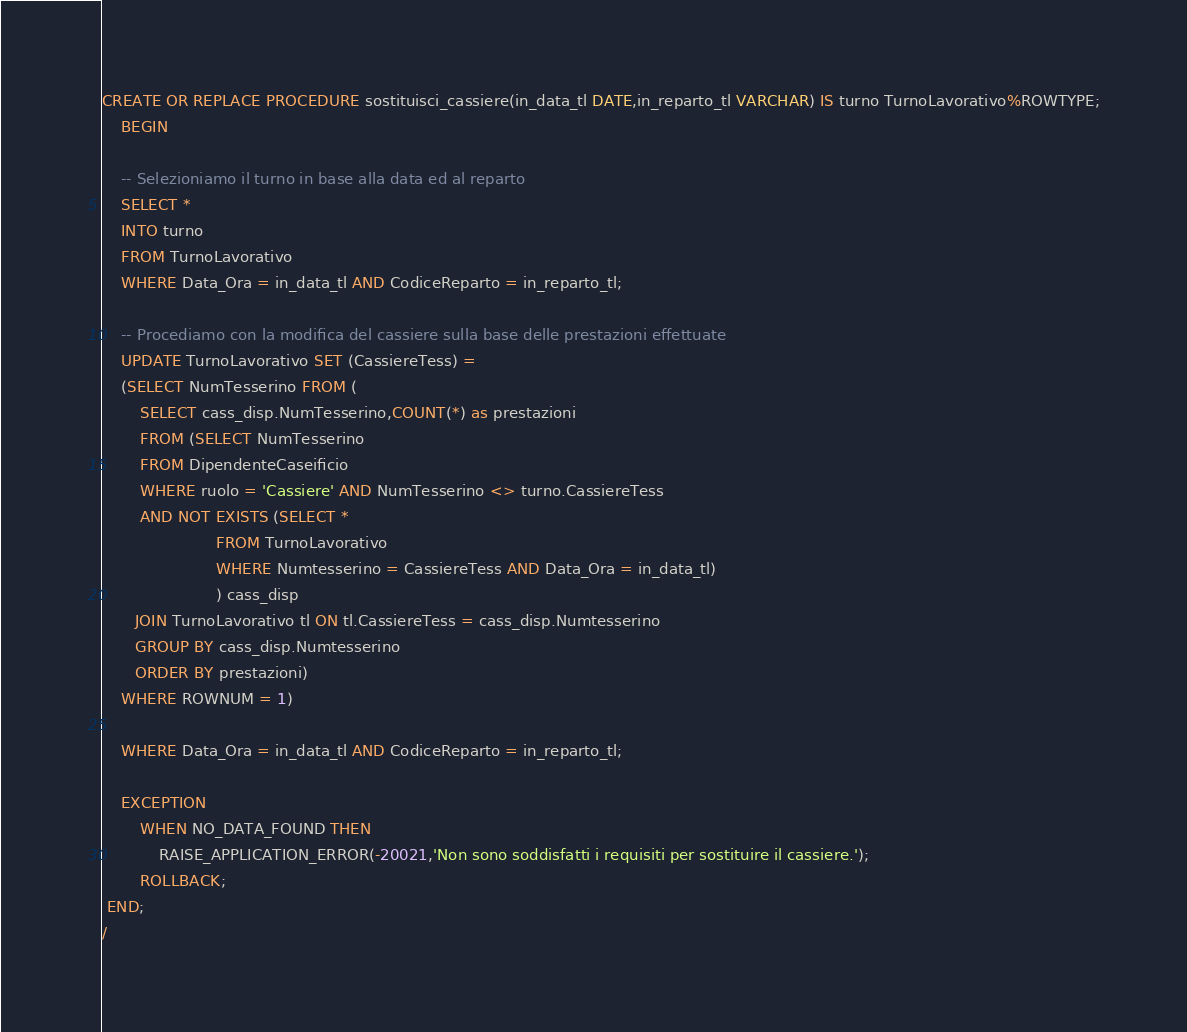<code> <loc_0><loc_0><loc_500><loc_500><_SQL_>CREATE OR REPLACE PROCEDURE sostituisci_cassiere(in_data_tl DATE,in_reparto_tl VARCHAR) IS turno TurnoLavorativo%ROWTYPE;
    BEGIN

    -- Selezioniamo il turno in base alla data ed al reparto
    SELECT *
    INTO turno
    FROM TurnoLavorativo
    WHERE Data_Ora = in_data_tl AND CodiceReparto = in_reparto_tl;
    
	-- Procediamo con la modifica del cassiere sulla base delle prestazioni effettuate
    UPDATE TurnoLavorativo SET (CassiereTess) = 
	(SELECT NumTesserino FROM (
	    SELECT cass_disp.NumTesserino,COUNT(*) as prestazioni
	    FROM (SELECT NumTesserino
	    FROM DipendenteCaseificio
	    WHERE ruolo = 'Cassiere' AND NumTesserino <> turno.CassiereTess
	    AND NOT EXISTS (SELECT * 
	                    FROM TurnoLavorativo 
	                    WHERE Numtesserino = CassiereTess AND Data_Ora = in_data_tl)
	                    ) cass_disp
	   JOIN TurnoLavorativo tl ON tl.CassiereTess = cass_disp.Numtesserino
	   GROUP BY cass_disp.Numtesserino
	   ORDER BY prestazioni)
	WHERE ROWNUM = 1)
	
	WHERE Data_Ora = in_data_tl AND CodiceReparto = in_reparto_tl;
	
	EXCEPTION
	    WHEN NO_DATA_FOUND THEN
	        RAISE_APPLICATION_ERROR(-20021,'Non sono soddisfatti i requisiti per sostituire il cassiere.');
		ROLLBACK;
 END;
/</code> 